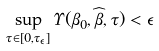Convert formula to latex. <formula><loc_0><loc_0><loc_500><loc_500>\sup _ { \tau \in [ 0 , \tau _ { \epsilon } ] } \Upsilon ( \beta _ { 0 } , \widehat { \beta } , \tau ) < \epsilon</formula> 